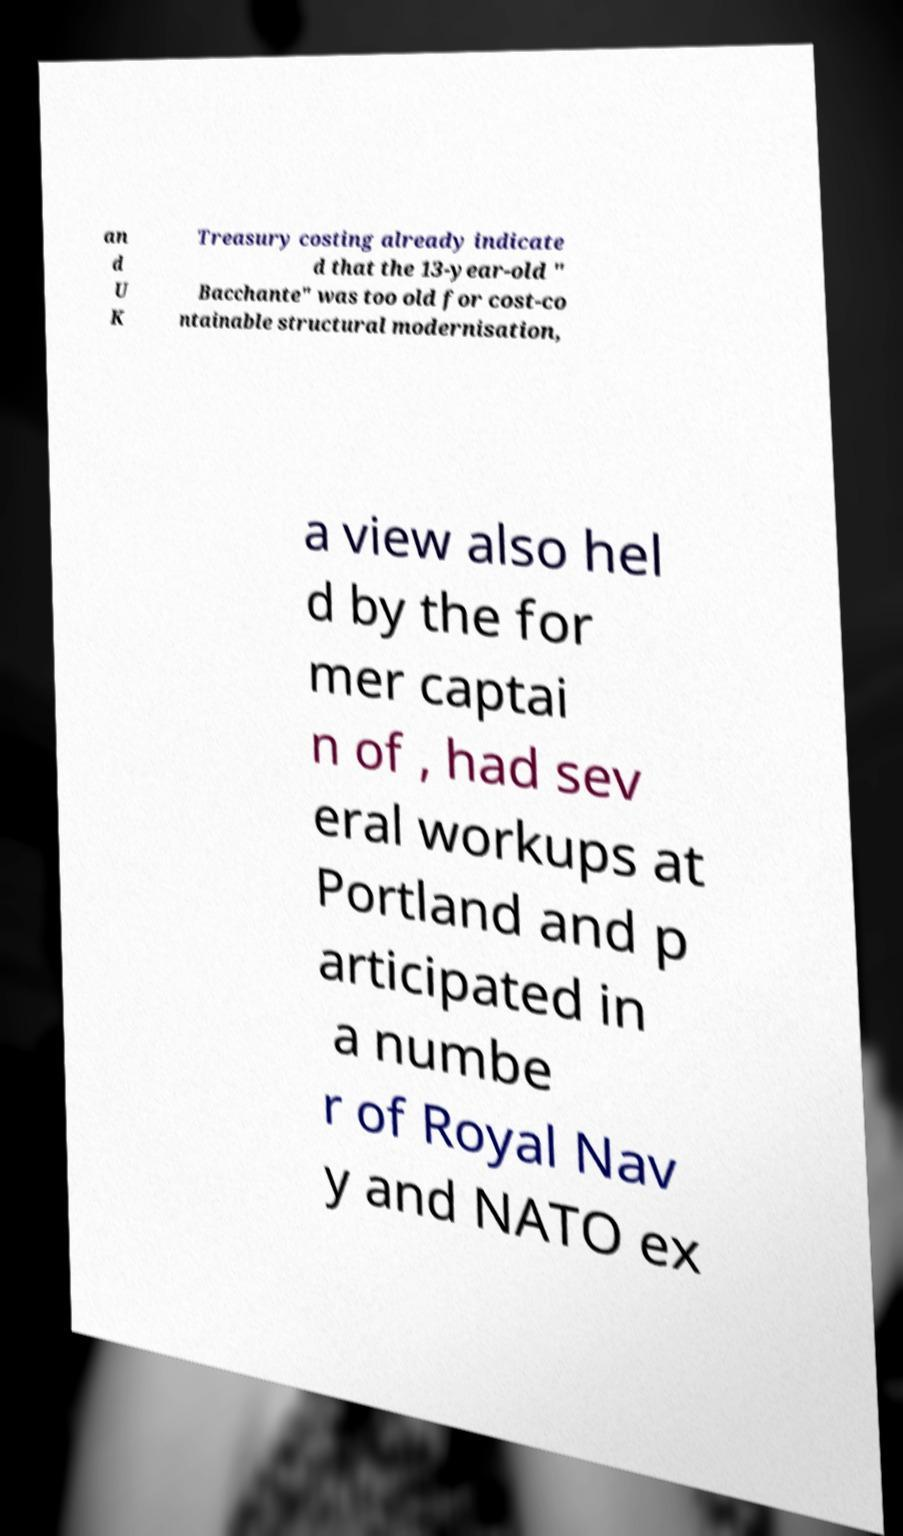For documentation purposes, I need the text within this image transcribed. Could you provide that? an d U K Treasury costing already indicate d that the 13-year-old " Bacchante" was too old for cost-co ntainable structural modernisation, a view also hel d by the for mer captai n of , had sev eral workups at Portland and p articipated in a numbe r of Royal Nav y and NATO ex 